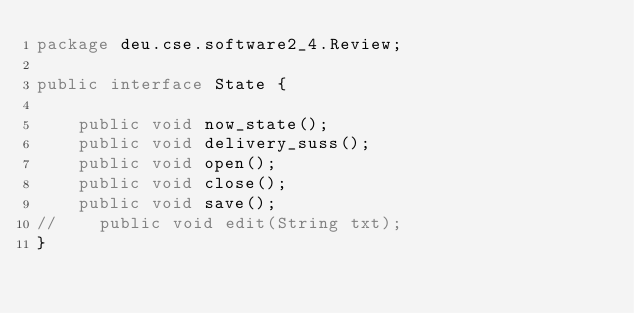Convert code to text. <code><loc_0><loc_0><loc_500><loc_500><_Java_>package deu.cse.software2_4.Review;

public interface State {

    public void now_state();
    public void delivery_suss();
    public void open();
    public void close();
    public void save();
//    public void edit(String txt);
}
</code> 